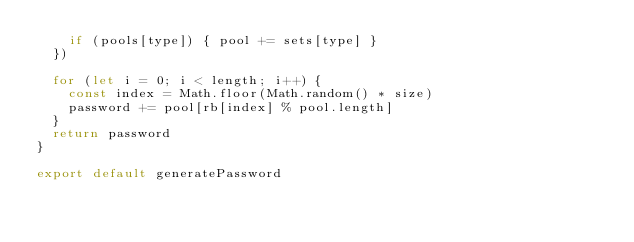Convert code to text. <code><loc_0><loc_0><loc_500><loc_500><_JavaScript_>    if (pools[type]) { pool += sets[type] }
  })

  for (let i = 0; i < length; i++) {
    const index = Math.floor(Math.random() * size)
    password += pool[rb[index] % pool.length]
  }
  return password
}

export default generatePassword
</code> 